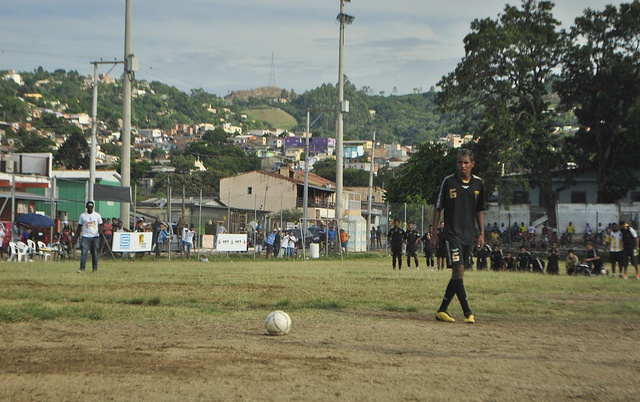Describe the objects in this image and their specific colors. I can see people in darkgray, gray, black, and lightgray tones, people in darkgray, black, and gray tones, people in darkgray, black, gray, and lightgray tones, people in darkgray, black, gray, and maroon tones, and people in darkgray, black, gray, and darkgreen tones in this image. 